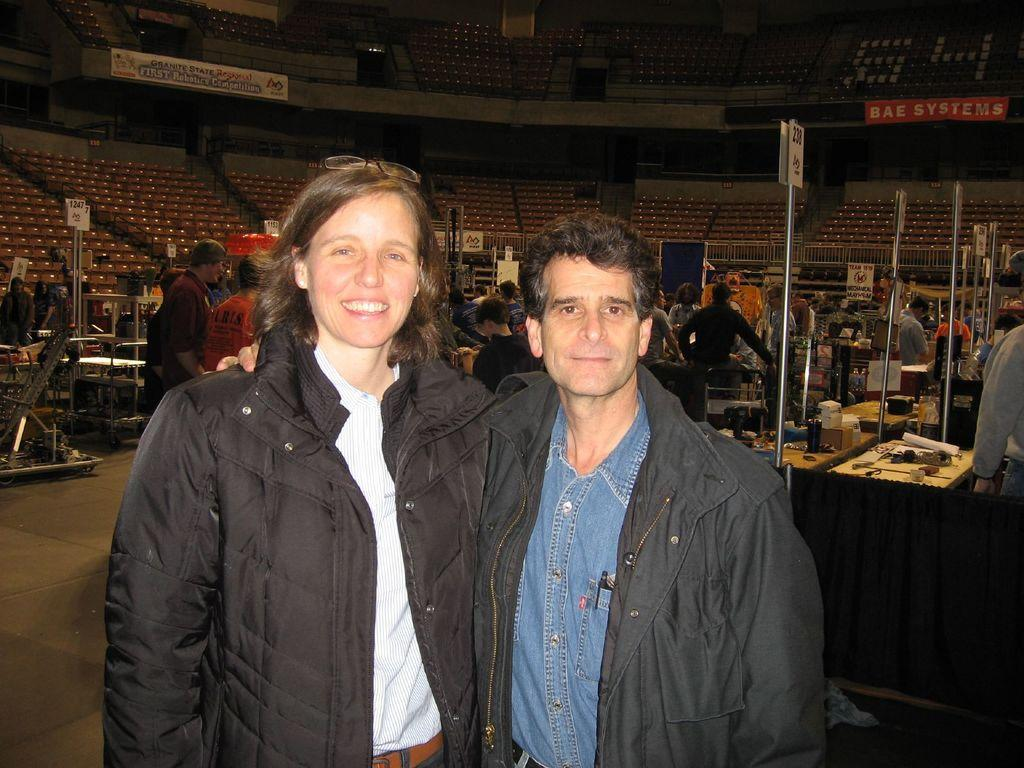How many people are present in the image? There are two persons in the image. What can be seen in the background of the image? In the background of the image, there are poles, boards, tables, chairs, hoardings, and railing. There are also people and objects present. Can you describe the setting of the image? The image appears to be set in an outdoor area with various structures and objects in the background. What type of wrist accessory is being worn by the person on the left in the image? There is no wrist accessory visible on the person on the left in the image. Is there any snow present in the image? No, there is no snow present in the image; it appears to be set in an outdoor area with no snow visible. 